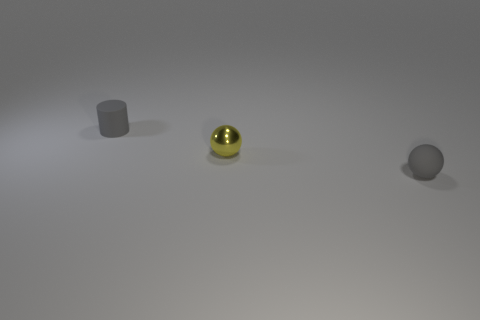The matte thing to the right of the small cylinder is what color?
Give a very brief answer. Gray. There is a thing that is the same color as the matte ball; what is its shape?
Provide a short and direct response. Cylinder. How many rubber objects have the same size as the yellow metallic object?
Offer a terse response. 2. Does the small gray thing that is in front of the shiny sphere have the same shape as the gray rubber thing that is to the left of the metallic sphere?
Your answer should be very brief. No. The yellow thing to the left of the tiny gray thing that is in front of the gray thing that is left of the tiny rubber sphere is made of what material?
Give a very brief answer. Metal. There is a gray object that is the same size as the gray rubber cylinder; what shape is it?
Offer a terse response. Sphere. Is there another thing of the same color as the small metal object?
Offer a very short reply. No. How big is the metallic thing?
Offer a terse response. Small. Is the material of the cylinder the same as the small yellow object?
Give a very brief answer. No. There is a tiny gray object on the left side of the gray object that is right of the tiny gray rubber cylinder; what number of small metal objects are right of it?
Provide a short and direct response. 1. 